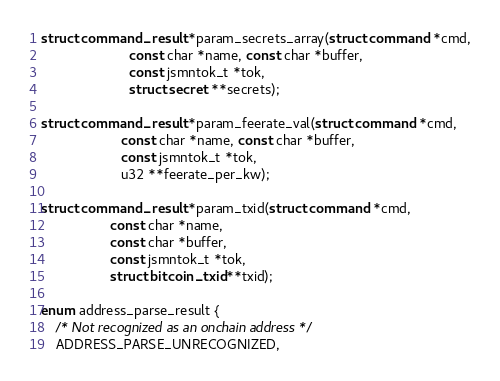<code> <loc_0><loc_0><loc_500><loc_500><_C_>
struct command_result *param_secrets_array(struct command *cmd,
					   const char *name, const char *buffer,
					   const jsmntok_t *tok,
					   struct secret **secrets);

struct command_result *param_feerate_val(struct command *cmd,
					 const char *name, const char *buffer,
					 const jsmntok_t *tok,
					 u32 **feerate_per_kw);

struct command_result *param_txid(struct command *cmd,
				  const char *name,
				  const char *buffer,
				  const jsmntok_t *tok,
				  struct bitcoin_txid **txid);

enum address_parse_result {
	/* Not recognized as an onchain address */
	ADDRESS_PARSE_UNRECOGNIZED,</code> 